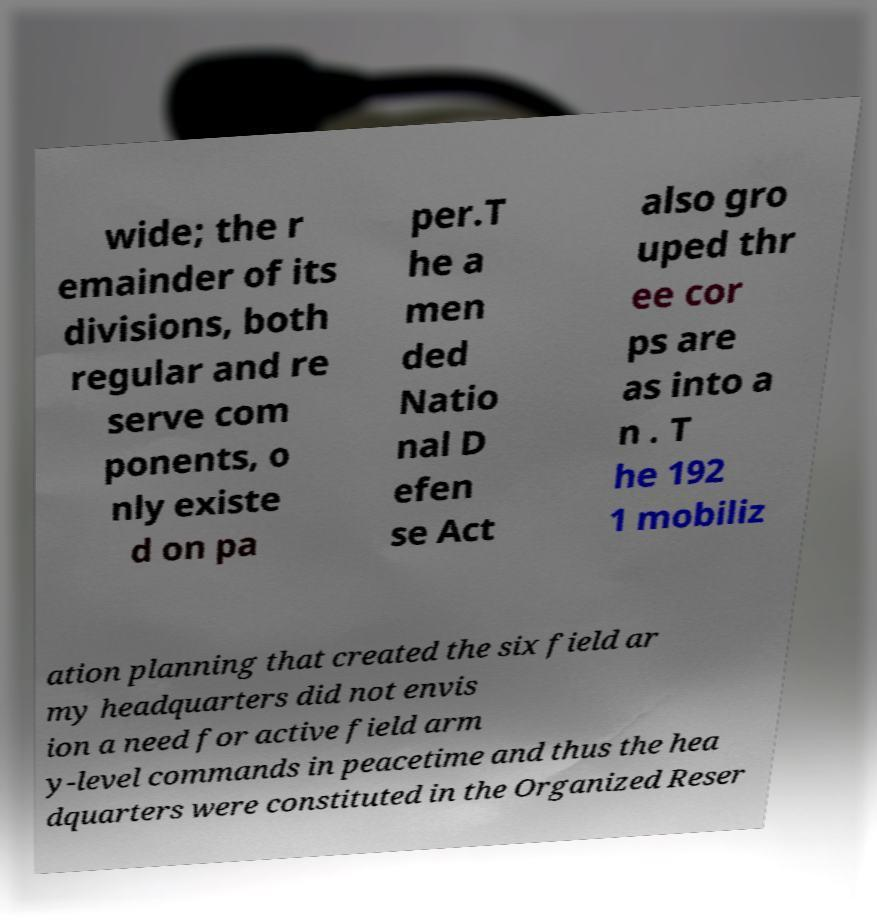Please identify and transcribe the text found in this image. wide; the r emainder of its divisions, both regular and re serve com ponents, o nly existe d on pa per.T he a men ded Natio nal D efen se Act also gro uped thr ee cor ps are as into a n . T he 192 1 mobiliz ation planning that created the six field ar my headquarters did not envis ion a need for active field arm y-level commands in peacetime and thus the hea dquarters were constituted in the Organized Reser 